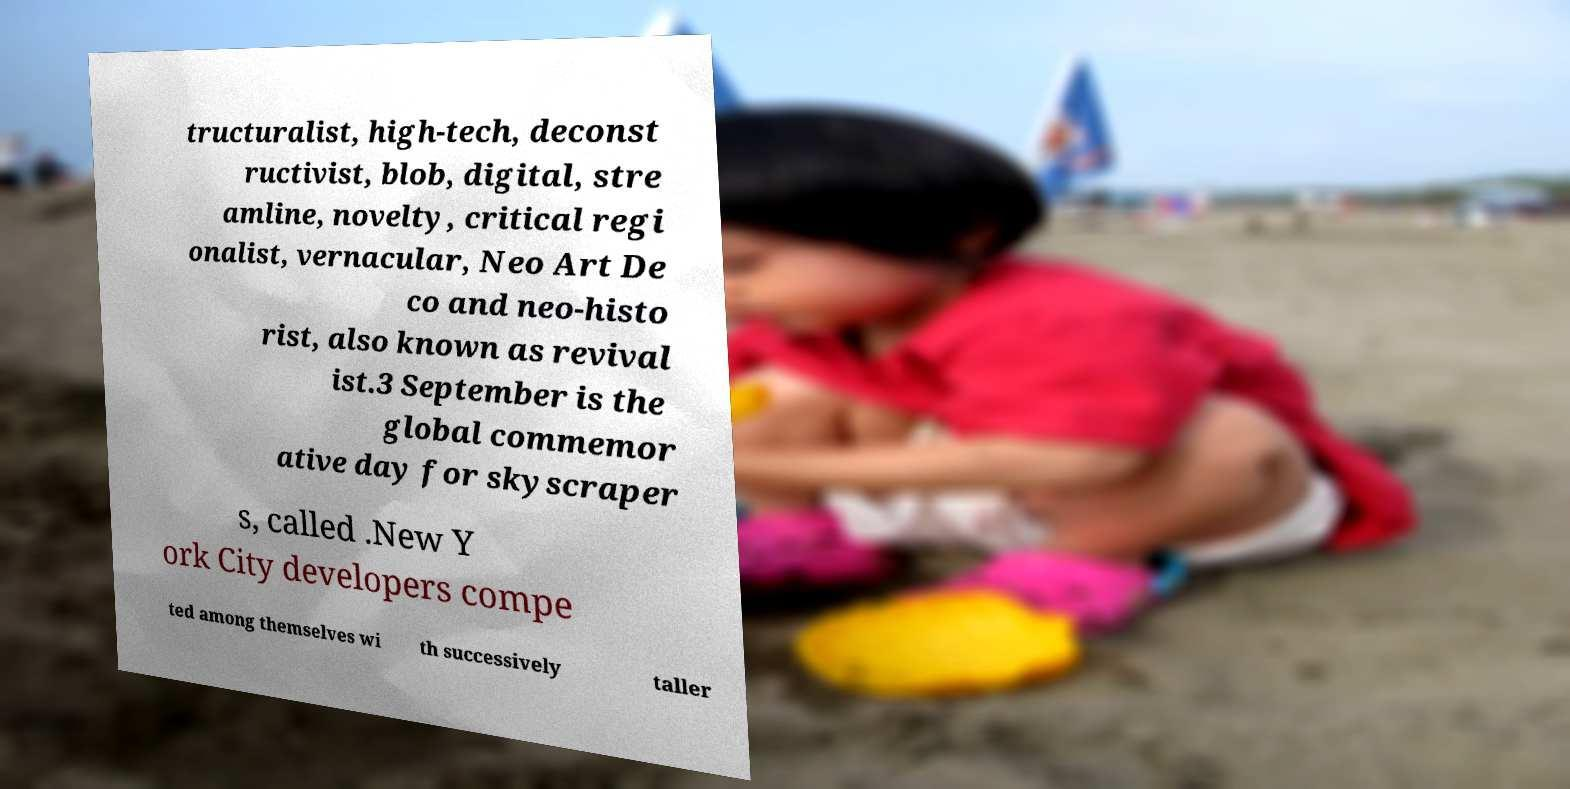Please read and relay the text visible in this image. What does it say? tructuralist, high-tech, deconst ructivist, blob, digital, stre amline, novelty, critical regi onalist, vernacular, Neo Art De co and neo-histo rist, also known as revival ist.3 September is the global commemor ative day for skyscraper s, called .New Y ork City developers compe ted among themselves wi th successively taller 